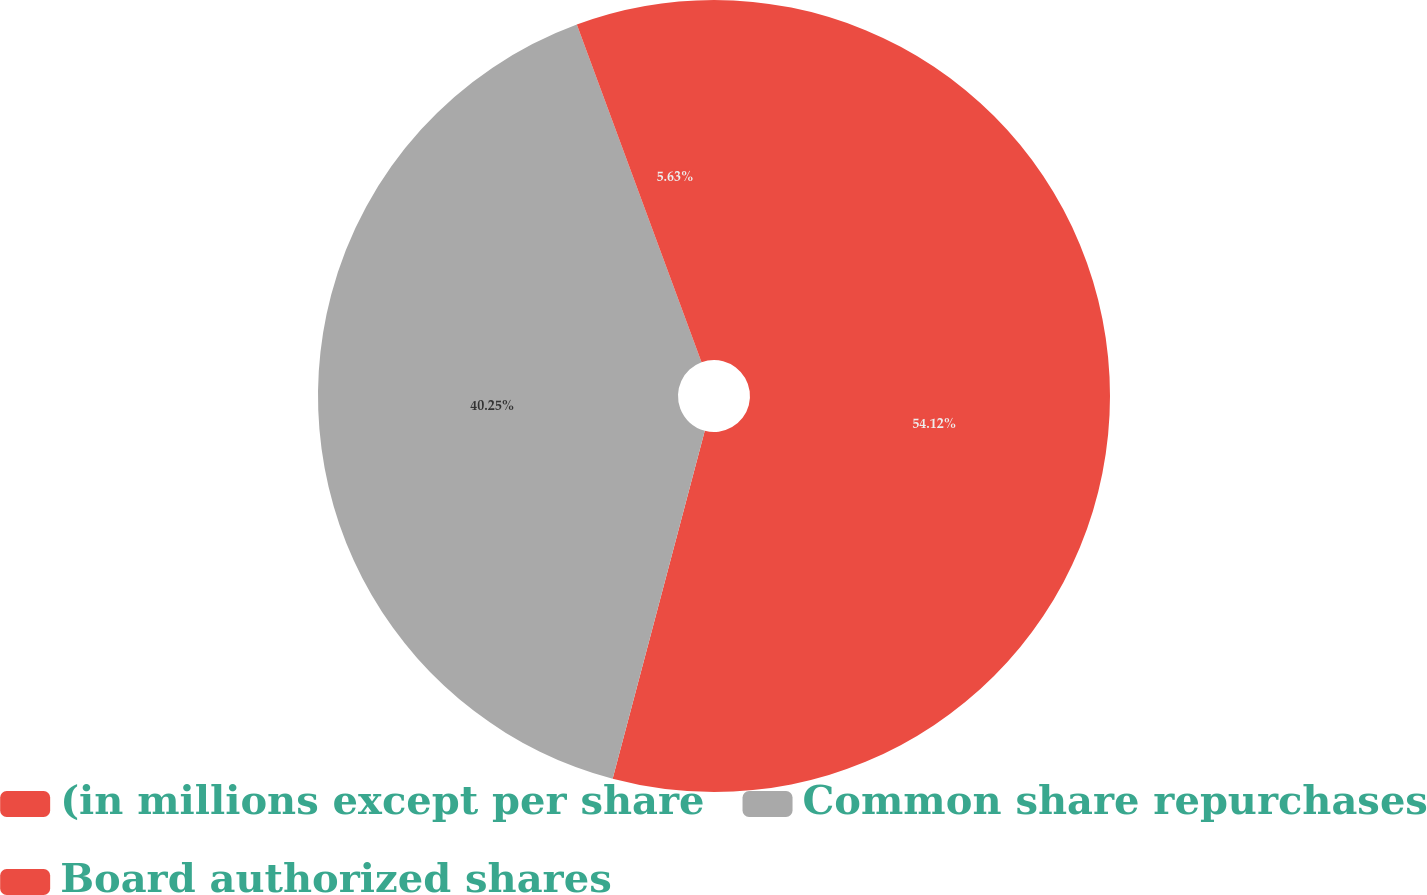<chart> <loc_0><loc_0><loc_500><loc_500><pie_chart><fcel>(in millions except per share<fcel>Common share repurchases<fcel>Board authorized shares<nl><fcel>54.12%<fcel>40.25%<fcel>5.63%<nl></chart> 